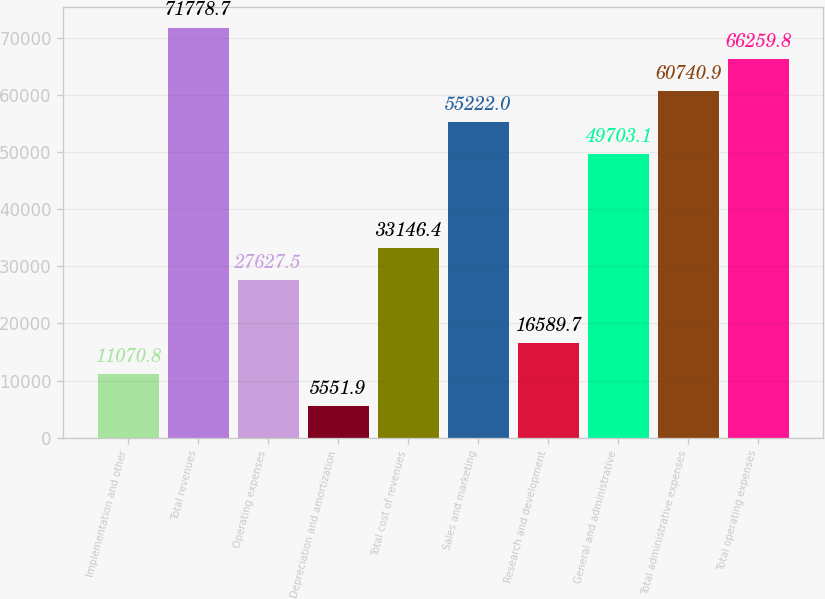<chart> <loc_0><loc_0><loc_500><loc_500><bar_chart><fcel>Implementation and other<fcel>Total revenues<fcel>Operating expenses<fcel>Depreciation and amortization<fcel>Total cost of revenues<fcel>Sales and marketing<fcel>Research and development<fcel>General and administrative<fcel>Total administrative expenses<fcel>Total operating expenses<nl><fcel>11070.8<fcel>71778.7<fcel>27627.5<fcel>5551.9<fcel>33146.4<fcel>55222<fcel>16589.7<fcel>49703.1<fcel>60740.9<fcel>66259.8<nl></chart> 